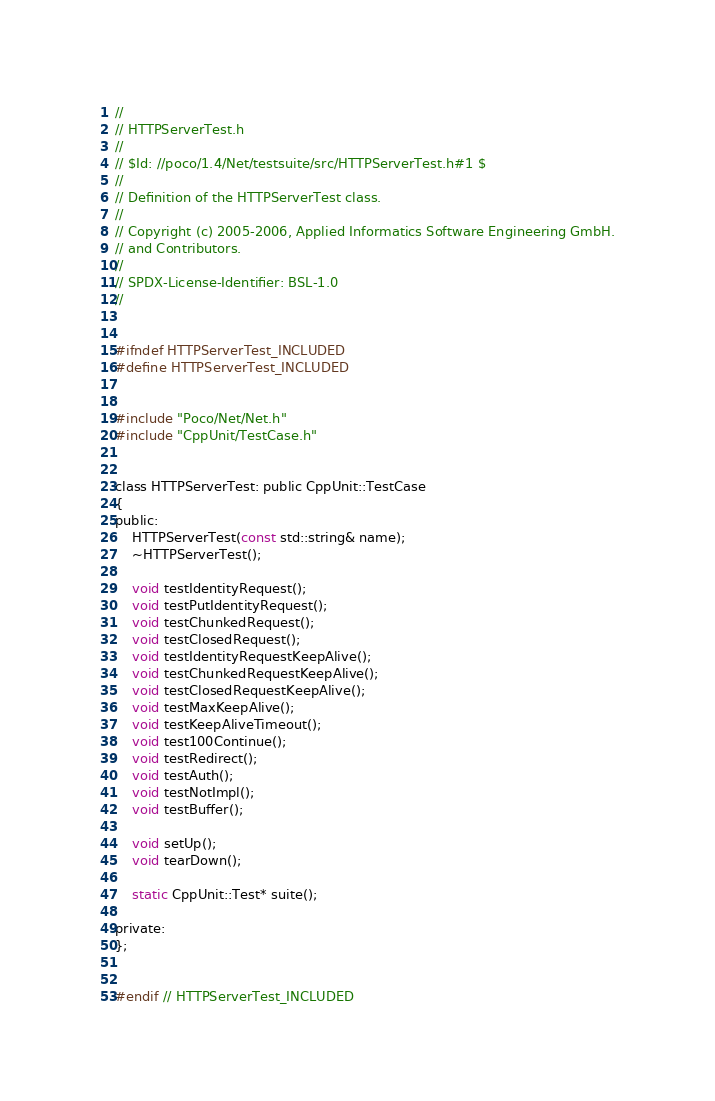Convert code to text. <code><loc_0><loc_0><loc_500><loc_500><_C_>//
// HTTPServerTest.h
//
// $Id: //poco/1.4/Net/testsuite/src/HTTPServerTest.h#1 $
//
// Definition of the HTTPServerTest class.
//
// Copyright (c) 2005-2006, Applied Informatics Software Engineering GmbH.
// and Contributors.
//
// SPDX-License-Identifier:	BSL-1.0
//


#ifndef HTTPServerTest_INCLUDED
#define HTTPServerTest_INCLUDED


#include "Poco/Net/Net.h"
#include "CppUnit/TestCase.h"


class HTTPServerTest: public CppUnit::TestCase
{
public:
	HTTPServerTest(const std::string& name);
	~HTTPServerTest();

	void testIdentityRequest();
	void testPutIdentityRequest();
	void testChunkedRequest();
	void testClosedRequest();
	void testIdentityRequestKeepAlive();
	void testChunkedRequestKeepAlive();
	void testClosedRequestKeepAlive();
	void testMaxKeepAlive();
	void testKeepAliveTimeout();
	void test100Continue();
	void testRedirect();
	void testAuth();
	void testNotImpl();
	void testBuffer();

	void setUp();
	void tearDown();

	static CppUnit::Test* suite();

private:
};


#endif // HTTPServerTest_INCLUDED
</code> 